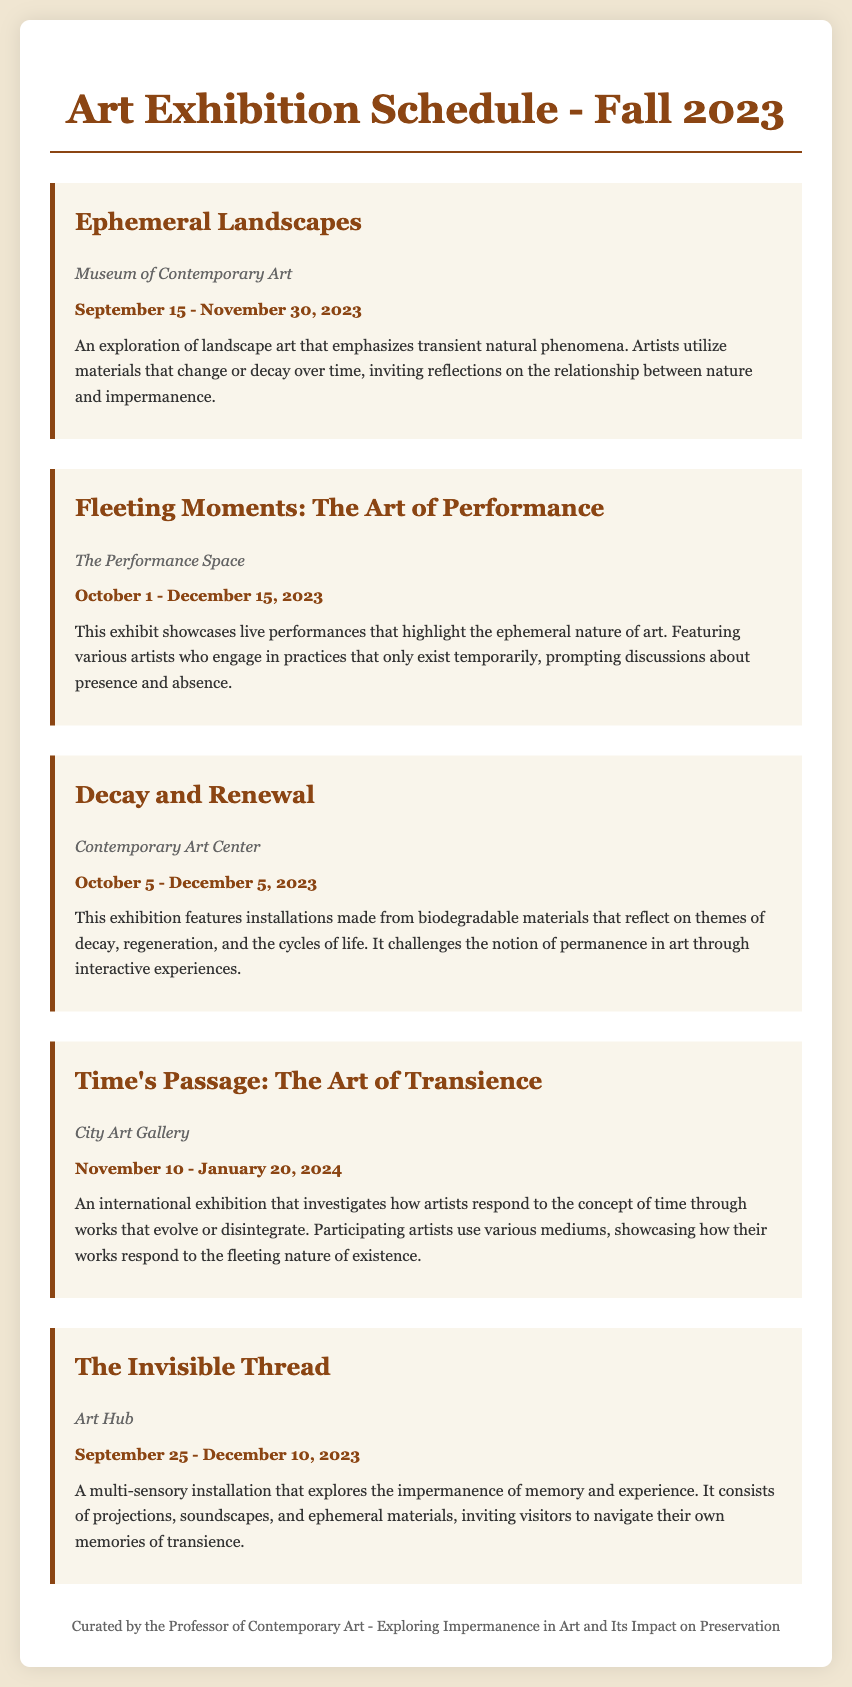What is the title of the exhibit exploring transient natural phenomena? The exhibit focuses on landscape art emphasizing transient natural phenomena, titled "Ephemeral Landscapes."
Answer: Ephemeral Landscapes What are the dates for the exhibit "Fleeting Moments: The Art of Performance"? The dates for this exhibit are provided in the schedule, running from October 1 to December 15, 2023.
Answer: October 1 - December 15, 2023 Which venue hosts the exhibition "Decay and Renewal"? The venue hosting this exhibit is specifically mentioned in the document, which is the Contemporary Art Center.
Answer: Contemporary Art Center How does the "Invisible Thread" exhibit explore memory? The exhibit is described as a multi-sensory installation focused on the impermanence of memory and experience through various artistic elements.
Answer: Impermanence of memory What is the main theme of the exhibit "Time's Passage: The Art of Transience"? This exhibition investigates artists' responses to the concept of time through evolving or disintegrating works, emphasizing transience.
Answer: Time and transience How many exhibits take place in the month of October? The schedule lists several exhibitions that occur during October, allowing for a calculation of the total number.
Answer: Three 